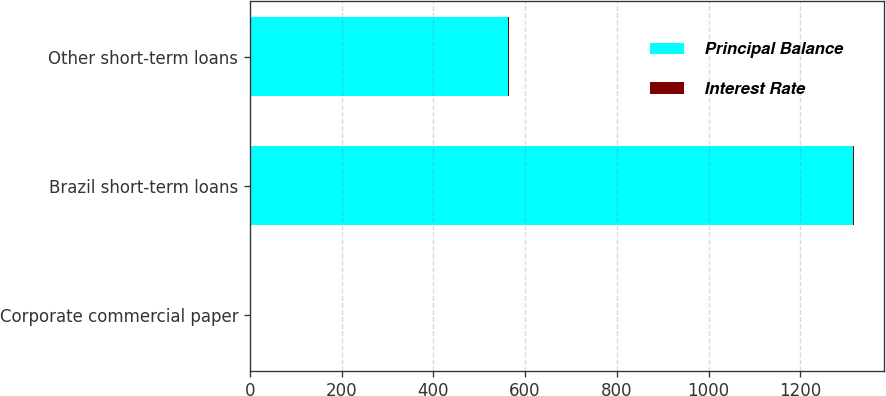<chart> <loc_0><loc_0><loc_500><loc_500><stacked_bar_chart><ecel><fcel>Corporate commercial paper<fcel>Brazil short-term loans<fcel>Other short-term loans<nl><fcel>Principal Balance<fcel>2.8<fcel>1314<fcel>563<nl><fcel>Interest Rate<fcel>0.3<fcel>2.8<fcel>1.8<nl></chart> 